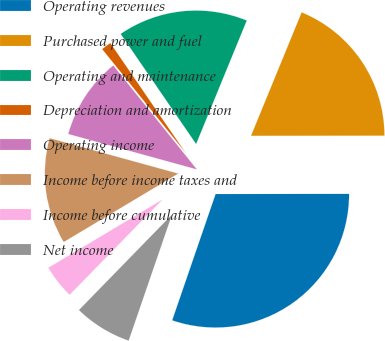Convert chart. <chart><loc_0><loc_0><loc_500><loc_500><pie_chart><fcel>Operating revenues<fcel>Purchased power and fuel<fcel>Operating and maintenance<fcel>Depreciation and amortization<fcel>Operating income<fcel>Income before income taxes and<fcel>Income before cumulative<fcel>Net income<nl><fcel>30.29%<fcel>18.79%<fcel>15.76%<fcel>1.22%<fcel>9.94%<fcel>12.85%<fcel>4.13%<fcel>7.03%<nl></chart> 